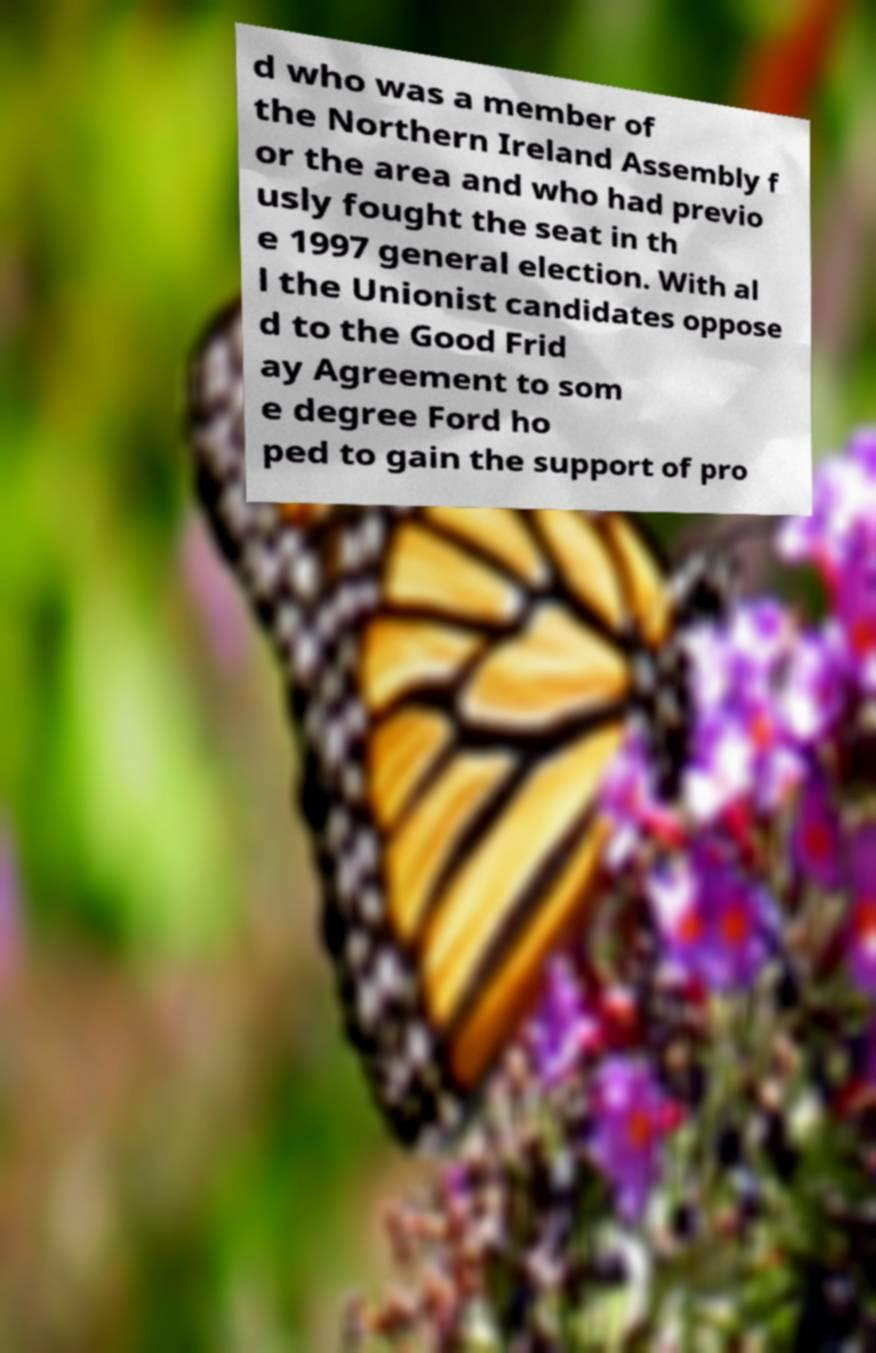For documentation purposes, I need the text within this image transcribed. Could you provide that? d who was a member of the Northern Ireland Assembly f or the area and who had previo usly fought the seat in th e 1997 general election. With al l the Unionist candidates oppose d to the Good Frid ay Agreement to som e degree Ford ho ped to gain the support of pro 